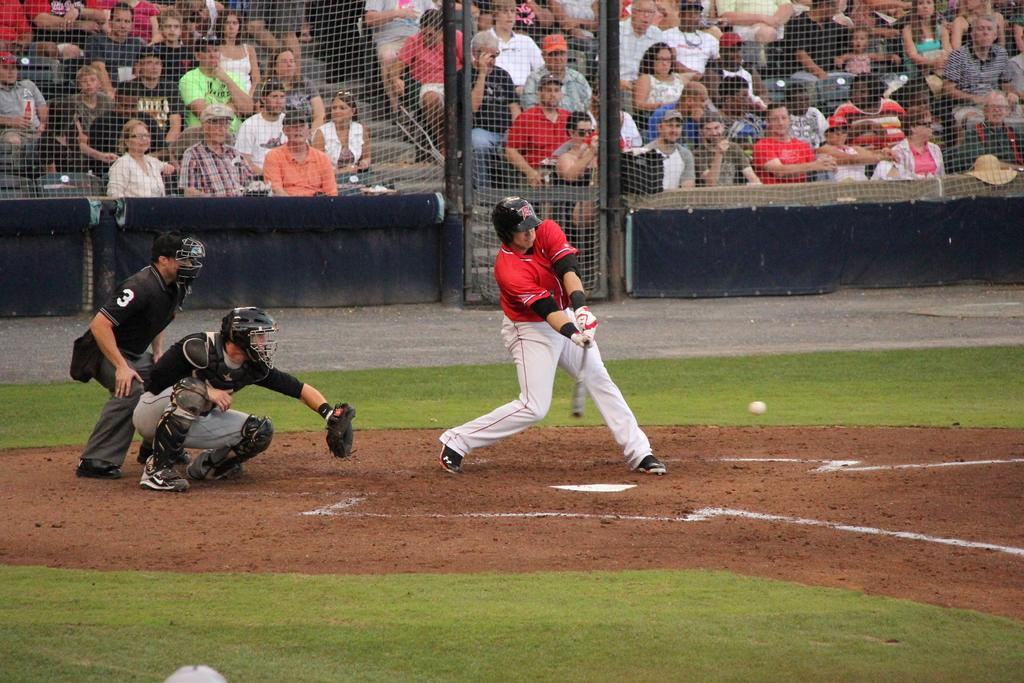<image>
Summarize the visual content of the image. A baseball player with an R on his helmet swings the bat, while the umpire #3 watches. 